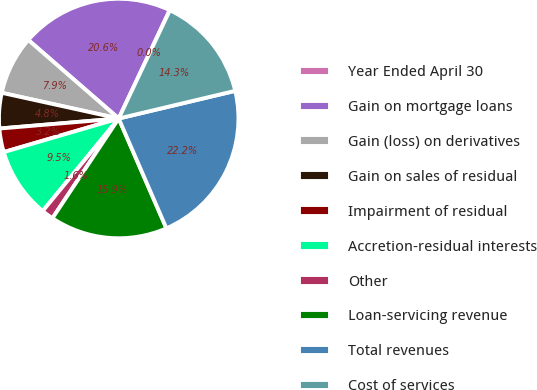Convert chart to OTSL. <chart><loc_0><loc_0><loc_500><loc_500><pie_chart><fcel>Year Ended April 30<fcel>Gain on mortgage loans<fcel>Gain (loss) on derivatives<fcel>Gain on sales of residual<fcel>Impairment of residual<fcel>Accretion-residual interests<fcel>Other<fcel>Loan-servicing revenue<fcel>Total revenues<fcel>Cost of services<nl><fcel>0.03%<fcel>20.61%<fcel>7.94%<fcel>4.78%<fcel>3.19%<fcel>9.53%<fcel>1.61%<fcel>15.86%<fcel>22.19%<fcel>14.27%<nl></chart> 